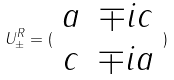<formula> <loc_0><loc_0><loc_500><loc_500>U _ { \pm } ^ { R } = ( \begin{array} { c c } a & \mp i c \\ c & \mp i a \end{array} )</formula> 